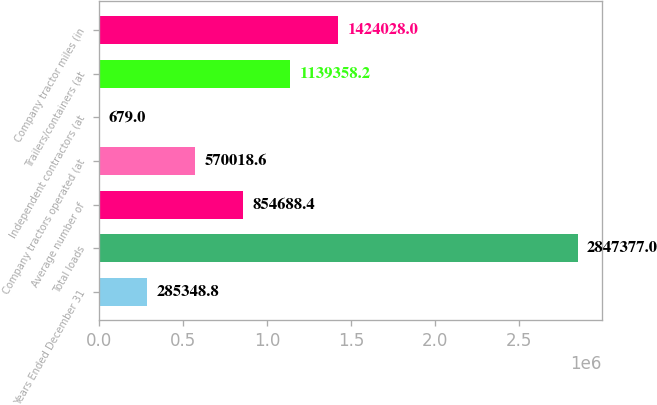<chart> <loc_0><loc_0><loc_500><loc_500><bar_chart><fcel>Years Ended December 31<fcel>Total loads<fcel>Average number of<fcel>Company tractors operated (at<fcel>Independent contractors (at<fcel>Trailers/containers (at<fcel>Company tractor miles (in<nl><fcel>285349<fcel>2.84738e+06<fcel>854688<fcel>570019<fcel>679<fcel>1.13936e+06<fcel>1.42403e+06<nl></chart> 